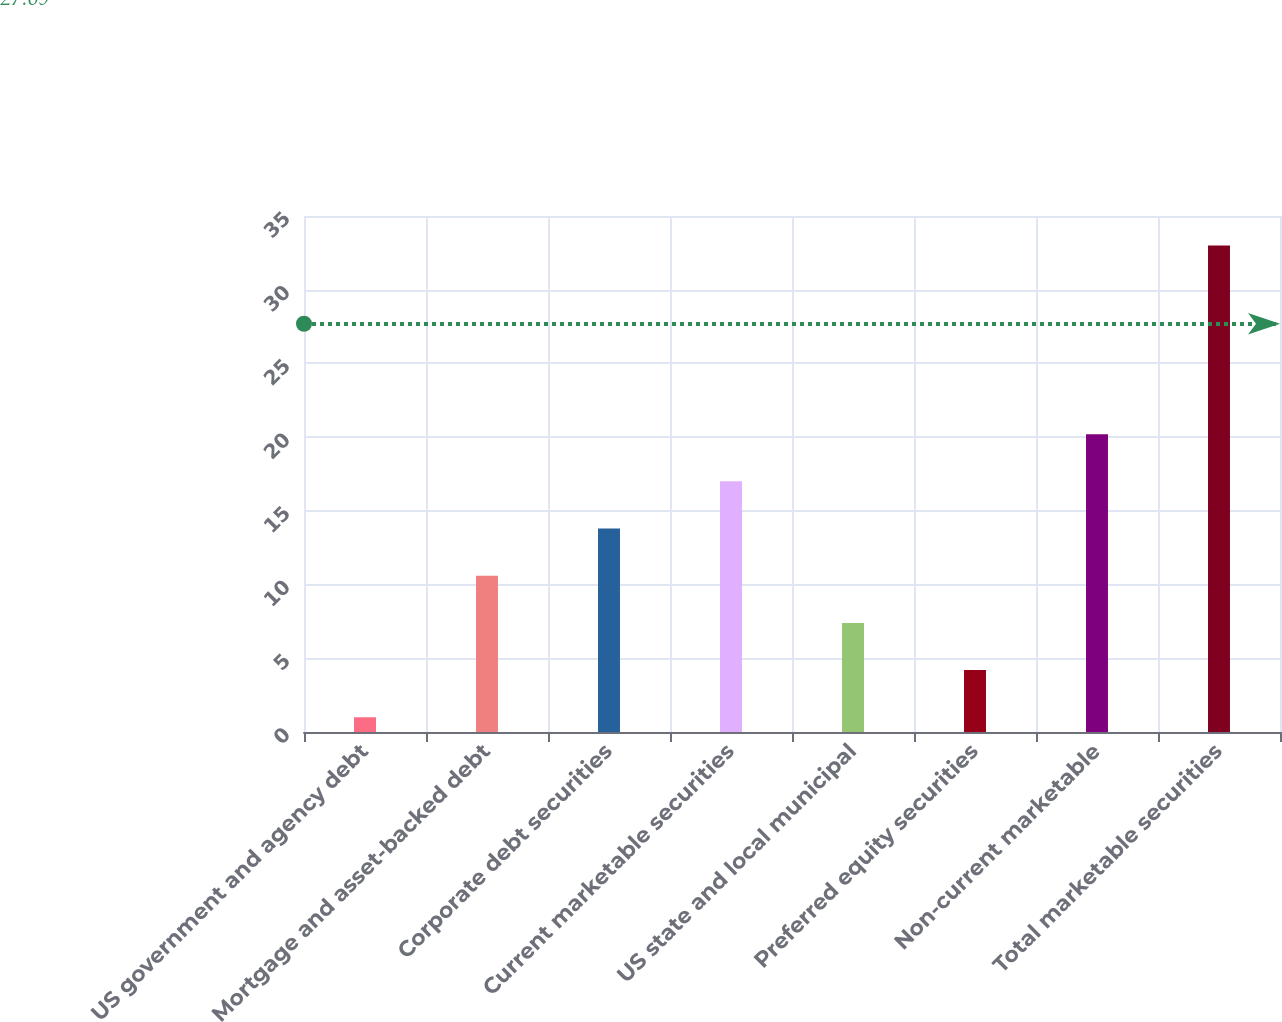Convert chart. <chart><loc_0><loc_0><loc_500><loc_500><bar_chart><fcel>US government and agency debt<fcel>Mortgage and asset-backed debt<fcel>Corporate debt securities<fcel>Current marketable securities<fcel>US state and local municipal<fcel>Preferred equity securities<fcel>Non-current marketable<fcel>Total marketable securities<nl><fcel>1<fcel>10.6<fcel>13.8<fcel>17<fcel>7.4<fcel>4.2<fcel>20.2<fcel>33<nl></chart> 